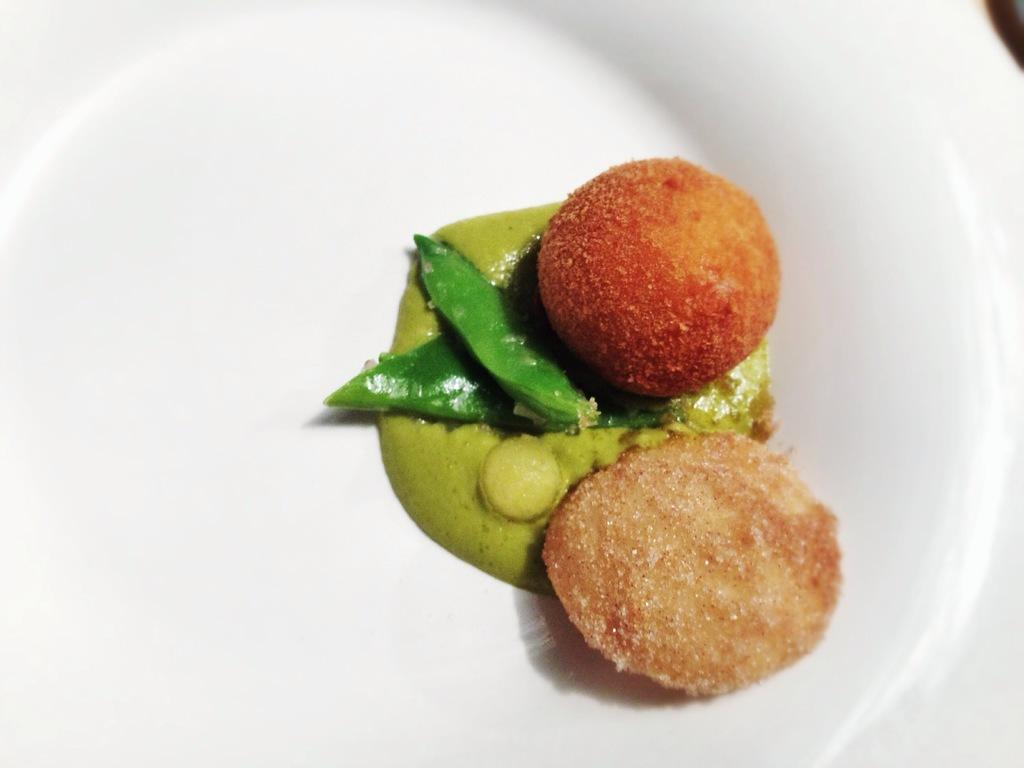What type of objects can be seen in the image? There are food items in the image. On what are the food items placed? The food items are on a white plate. What type of detail can be seen on the food items in the image? There is no specific detail mentioned on the food items in the provided facts. Can you see a rifle or a hammer in the image? No, there is no rifle or hammer present in the image. 